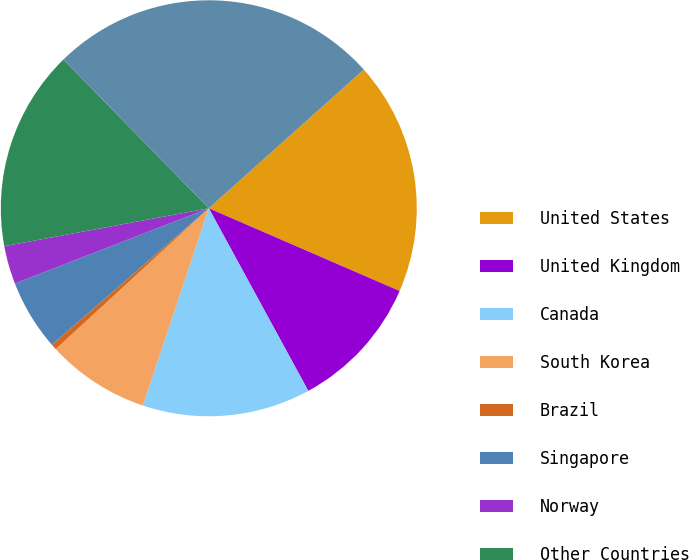Convert chart to OTSL. <chart><loc_0><loc_0><loc_500><loc_500><pie_chart><fcel>United States<fcel>United Kingdom<fcel>Canada<fcel>South Korea<fcel>Brazil<fcel>Singapore<fcel>Norway<fcel>Other Countries<fcel>Total<nl><fcel>18.13%<fcel>10.55%<fcel>13.08%<fcel>8.02%<fcel>0.45%<fcel>5.5%<fcel>2.97%<fcel>15.6%<fcel>25.7%<nl></chart> 